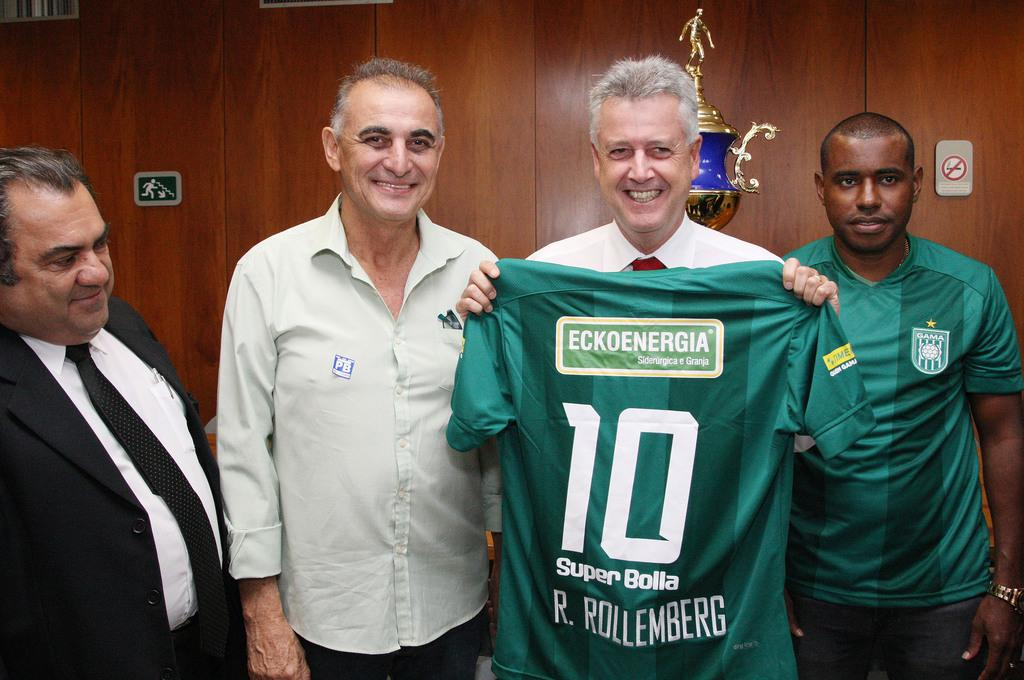Provide a one-sentence caption for the provided image. smiling men in a conference room hold up a green Super Bolta 10 jersey. 